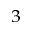Convert formula to latex. <formula><loc_0><loc_0><loc_500><loc_500>_ { 3 }</formula> 